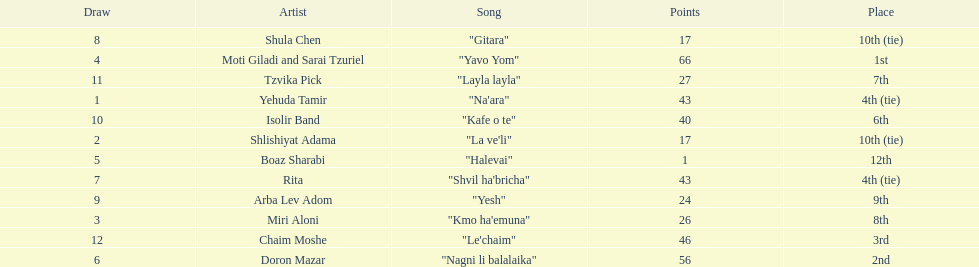Can you parse all the data within this table? {'header': ['Draw', 'Artist', 'Song', 'Points', 'Place'], 'rows': [['8', 'Shula Chen', '"Gitara"', '17', '10th (tie)'], ['4', 'Moti Giladi and Sarai Tzuriel', '"Yavo Yom"', '66', '1st'], ['11', 'Tzvika Pick', '"Layla layla"', '27', '7th'], ['1', 'Yehuda Tamir', '"Na\'ara"', '43', '4th (tie)'], ['10', 'Isolir Band', '"Kafe o te"', '40', '6th'], ['2', 'Shlishiyat Adama', '"La ve\'li"', '17', '10th (tie)'], ['5', 'Boaz Sharabi', '"Halevai"', '1', '12th'], ['7', 'Rita', '"Shvil ha\'bricha"', '43', '4th (tie)'], ['9', 'Arba Lev Adom', '"Yesh"', '24', '9th'], ['3', 'Miri Aloni', '"Kmo ha\'emuna"', '26', '8th'], ['12', 'Chaim Moshe', '"Le\'chaim"', '46', '3rd'], ['6', 'Doron Mazar', '"Nagni li balalaika"', '56', '2nd']]} What is the name of the song listed before the song "yesh"? "Gitara". 